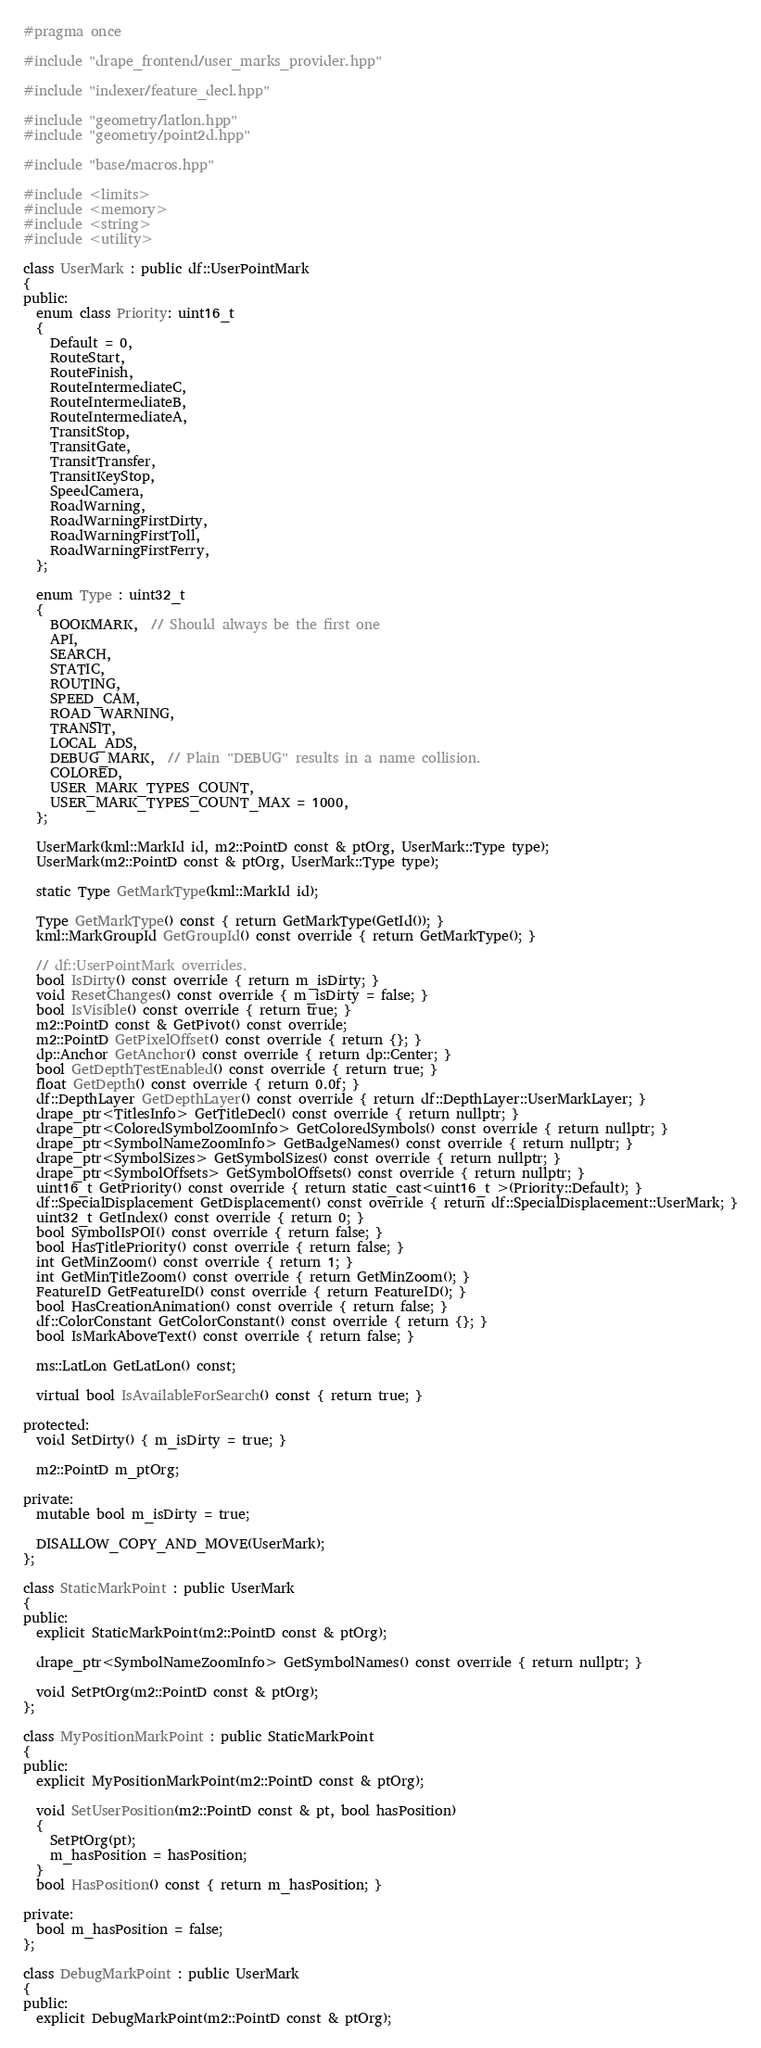<code> <loc_0><loc_0><loc_500><loc_500><_C++_>#pragma once

#include "drape_frontend/user_marks_provider.hpp"

#include "indexer/feature_decl.hpp"

#include "geometry/latlon.hpp"
#include "geometry/point2d.hpp"

#include "base/macros.hpp"

#include <limits>
#include <memory>
#include <string>
#include <utility>

class UserMark : public df::UserPointMark
{
public:
  enum class Priority: uint16_t
  {
    Default = 0,
    RouteStart,
    RouteFinish,
    RouteIntermediateC,
    RouteIntermediateB,
    RouteIntermediateA,
    TransitStop,
    TransitGate,
    TransitTransfer,
    TransitKeyStop,
    SpeedCamera,
    RoadWarning,
    RoadWarningFirstDirty,
    RoadWarningFirstToll,
    RoadWarningFirstFerry,
  };

  enum Type : uint32_t
  {
    BOOKMARK,  // Should always be the first one
    API,
    SEARCH,
    STATIC,
    ROUTING,
    SPEED_CAM,
    ROAD_WARNING,
    TRANSIT,
    LOCAL_ADS,
    DEBUG_MARK,  // Plain "DEBUG" results in a name collision.
    COLORED,
    USER_MARK_TYPES_COUNT,
    USER_MARK_TYPES_COUNT_MAX = 1000,
  };

  UserMark(kml::MarkId id, m2::PointD const & ptOrg, UserMark::Type type);
  UserMark(m2::PointD const & ptOrg, UserMark::Type type);

  static Type GetMarkType(kml::MarkId id);

  Type GetMarkType() const { return GetMarkType(GetId()); }
  kml::MarkGroupId GetGroupId() const override { return GetMarkType(); }

  // df::UserPointMark overrides.
  bool IsDirty() const override { return m_isDirty; }
  void ResetChanges() const override { m_isDirty = false; }
  bool IsVisible() const override { return true; }
  m2::PointD const & GetPivot() const override;
  m2::PointD GetPixelOffset() const override { return {}; }
  dp::Anchor GetAnchor() const override { return dp::Center; }
  bool GetDepthTestEnabled() const override { return true; }
  float GetDepth() const override { return 0.0f; }
  df::DepthLayer GetDepthLayer() const override { return df::DepthLayer::UserMarkLayer; }
  drape_ptr<TitlesInfo> GetTitleDecl() const override { return nullptr; }
  drape_ptr<ColoredSymbolZoomInfo> GetColoredSymbols() const override { return nullptr; }
  drape_ptr<SymbolNameZoomInfo> GetBadgeNames() const override { return nullptr; }
  drape_ptr<SymbolSizes> GetSymbolSizes() const override { return nullptr; }
  drape_ptr<SymbolOffsets> GetSymbolOffsets() const override { return nullptr; }
  uint16_t GetPriority() const override { return static_cast<uint16_t >(Priority::Default); }
  df::SpecialDisplacement GetDisplacement() const override { return df::SpecialDisplacement::UserMark; }
  uint32_t GetIndex() const override { return 0; }
  bool SymbolIsPOI() const override { return false; }
  bool HasTitlePriority() const override { return false; }
  int GetMinZoom() const override { return 1; }
  int GetMinTitleZoom() const override { return GetMinZoom(); }
  FeatureID GetFeatureID() const override { return FeatureID(); }
  bool HasCreationAnimation() const override { return false; }
  df::ColorConstant GetColorConstant() const override { return {}; }
  bool IsMarkAboveText() const override { return false; }

  ms::LatLon GetLatLon() const;

  virtual bool IsAvailableForSearch() const { return true; }

protected:
  void SetDirty() { m_isDirty = true; }

  m2::PointD m_ptOrg;

private:
  mutable bool m_isDirty = true;

  DISALLOW_COPY_AND_MOVE(UserMark);
};

class StaticMarkPoint : public UserMark
{
public:
  explicit StaticMarkPoint(m2::PointD const & ptOrg);

  drape_ptr<SymbolNameZoomInfo> GetSymbolNames() const override { return nullptr; }

  void SetPtOrg(m2::PointD const & ptOrg);
};

class MyPositionMarkPoint : public StaticMarkPoint
{
public:
  explicit MyPositionMarkPoint(m2::PointD const & ptOrg);

  void SetUserPosition(m2::PointD const & pt, bool hasPosition)
  {
    SetPtOrg(pt);
    m_hasPosition = hasPosition;
  }
  bool HasPosition() const { return m_hasPosition; }

private:
  bool m_hasPosition = false;
};

class DebugMarkPoint : public UserMark
{
public:
  explicit DebugMarkPoint(m2::PointD const & ptOrg);
</code> 